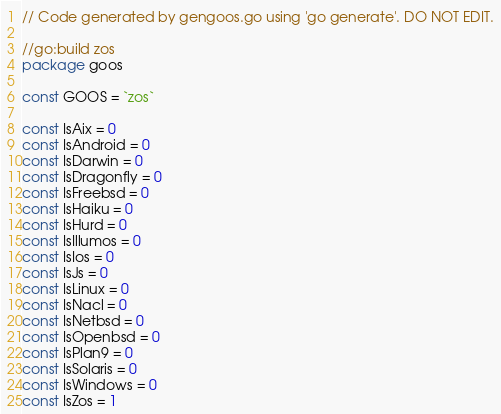<code> <loc_0><loc_0><loc_500><loc_500><_Go_>// Code generated by gengoos.go using 'go generate'. DO NOT EDIT.

//go:build zos
package goos

const GOOS = `zos`

const IsAix = 0
const IsAndroid = 0
const IsDarwin = 0
const IsDragonfly = 0
const IsFreebsd = 0
const IsHaiku = 0
const IsHurd = 0
const IsIllumos = 0
const IsIos = 0
const IsJs = 0
const IsLinux = 0
const IsNacl = 0
const IsNetbsd = 0
const IsOpenbsd = 0
const IsPlan9 = 0
const IsSolaris = 0
const IsWindows = 0
const IsZos = 1
</code> 